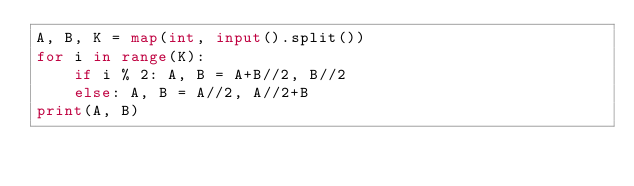<code> <loc_0><loc_0><loc_500><loc_500><_Python_>A, B, K = map(int, input().split())
for i in range(K):
    if i % 2: A, B = A+B//2, B//2
    else: A, B = A//2, A//2+B
print(A, B)
</code> 